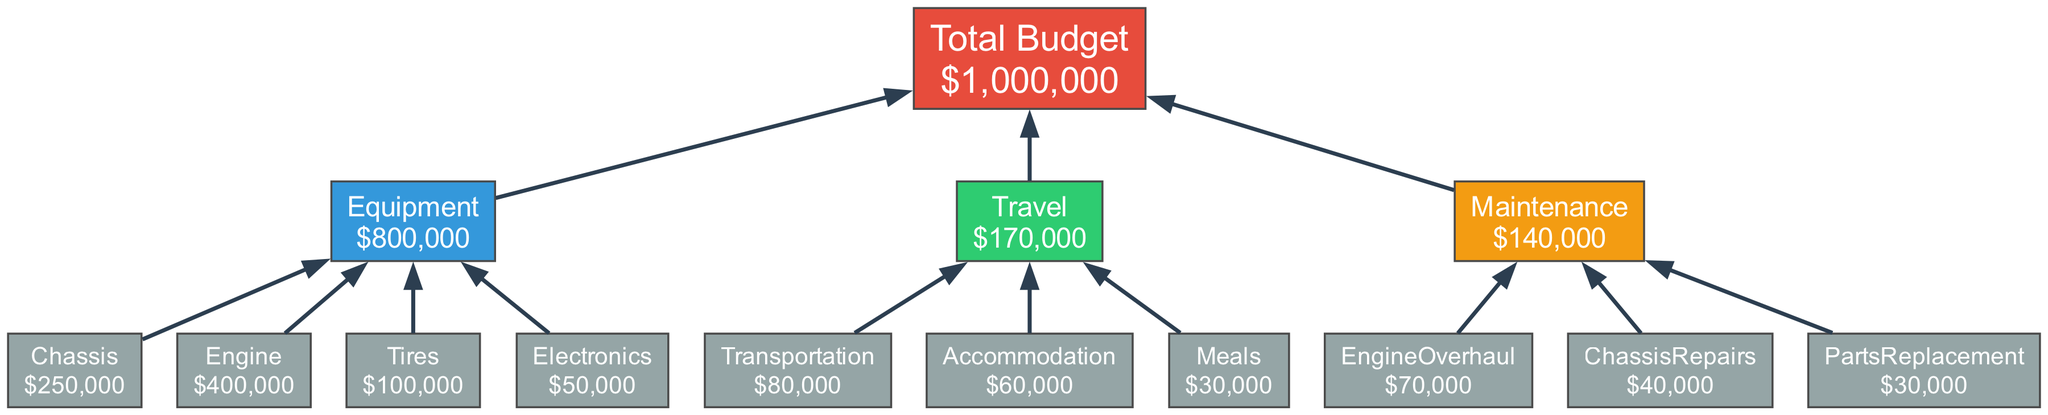What is the total budget for the racing season? The total budget is found in the Total Budget node, which shows an amount of 1,000,000.
Answer: 1,000,000 How much is allocated for equipment? To find the amount for equipment, sum the individual amounts under the Equipment category: 250,000 (Chassis) + 400,000 (Engine) + 100,000 (Tires) + 50,000 (Electronics), which equals 800,000.
Answer: 800,000 What is the cost of Engine Overhaul in the maintenance category? The Engine Overhaul expense is directly listed in the Maintenance category with an amount of 70,000.
Answer: 70,000 How many nodes are representing individual expense items? Each expense item is represented by a node under their respective categories (Equipment, Travel, and Maintenance). There are 9 individual expense nodes: Chassis, Engine, Tires, Electronics, Transportation, Accommodation, Meals, Engine Overhaul, Chassis Repairs, and Parts Replacement.
Answer: 9 What is the total expenditure for Travel? To find the total for Travel, sum the listed expenses: 80,000 (Transportation) + 60,000 (Accommodation) + 30,000 (Meals), resulting in 170,000.
Answer: 170,000 Which category has the highest total expense? Evaluating the totals of each category: Equipment has 800,000, Travel has 170,000, and Maintenance has 140,000. Thus, Equipment has the highest total expense.
Answer: Equipment What is the color of the Maintenance category node? The Maintenance category node is specified in the diagram with a color code of #f39c12.
Answer: #f39c12 How much is spent on Tires? The amount spent on Tires is directly noted as 100,000, listed under the Equipment category.
Answer: 100,000 What are the total expenses for Chassis Repairs and Parts Replacement combined? To find the combined total for Chassis Repairs and Parts Replacement, add both amounts: 40,000 (Chassis Repairs) + 30,000 (Parts Replacement), which equals 70,000.
Answer: 70,000 